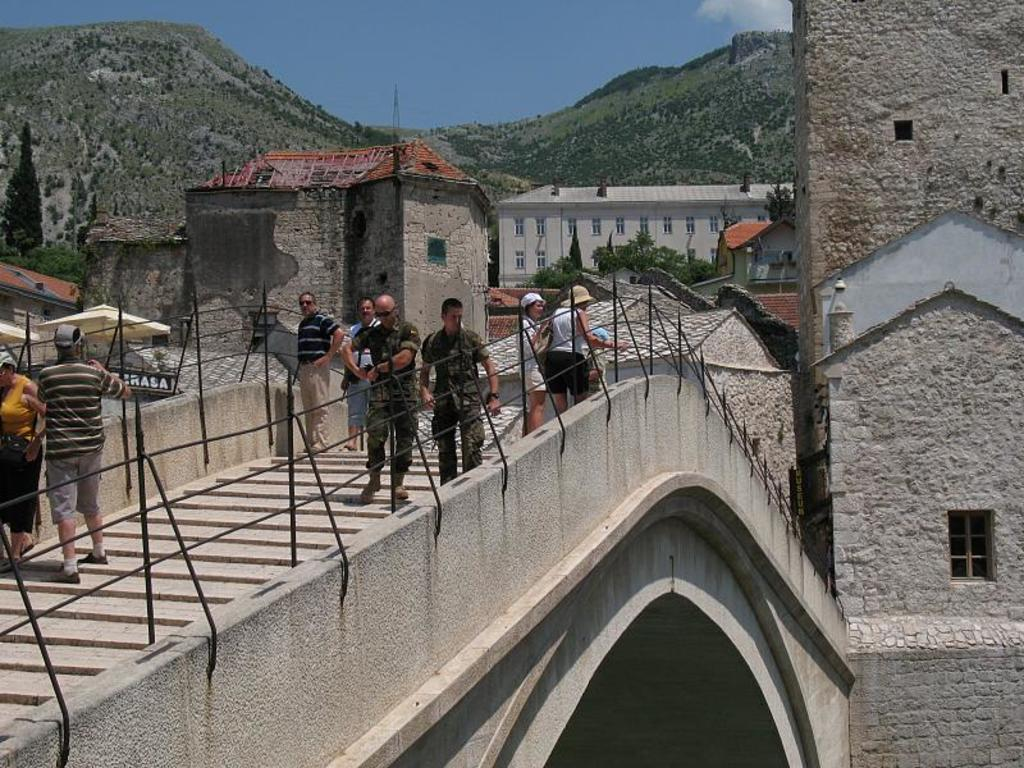What are the people in the image doing? The people in the image are standing on the bridge and railings. What can be seen in the background of the image? There are buildings, windows, trees, mountains, and clouds visible in the background. What type of addition problem can be solved using the circles in the image? There are no circles present in the image, so it is not possible to solve an addition problem using them. 